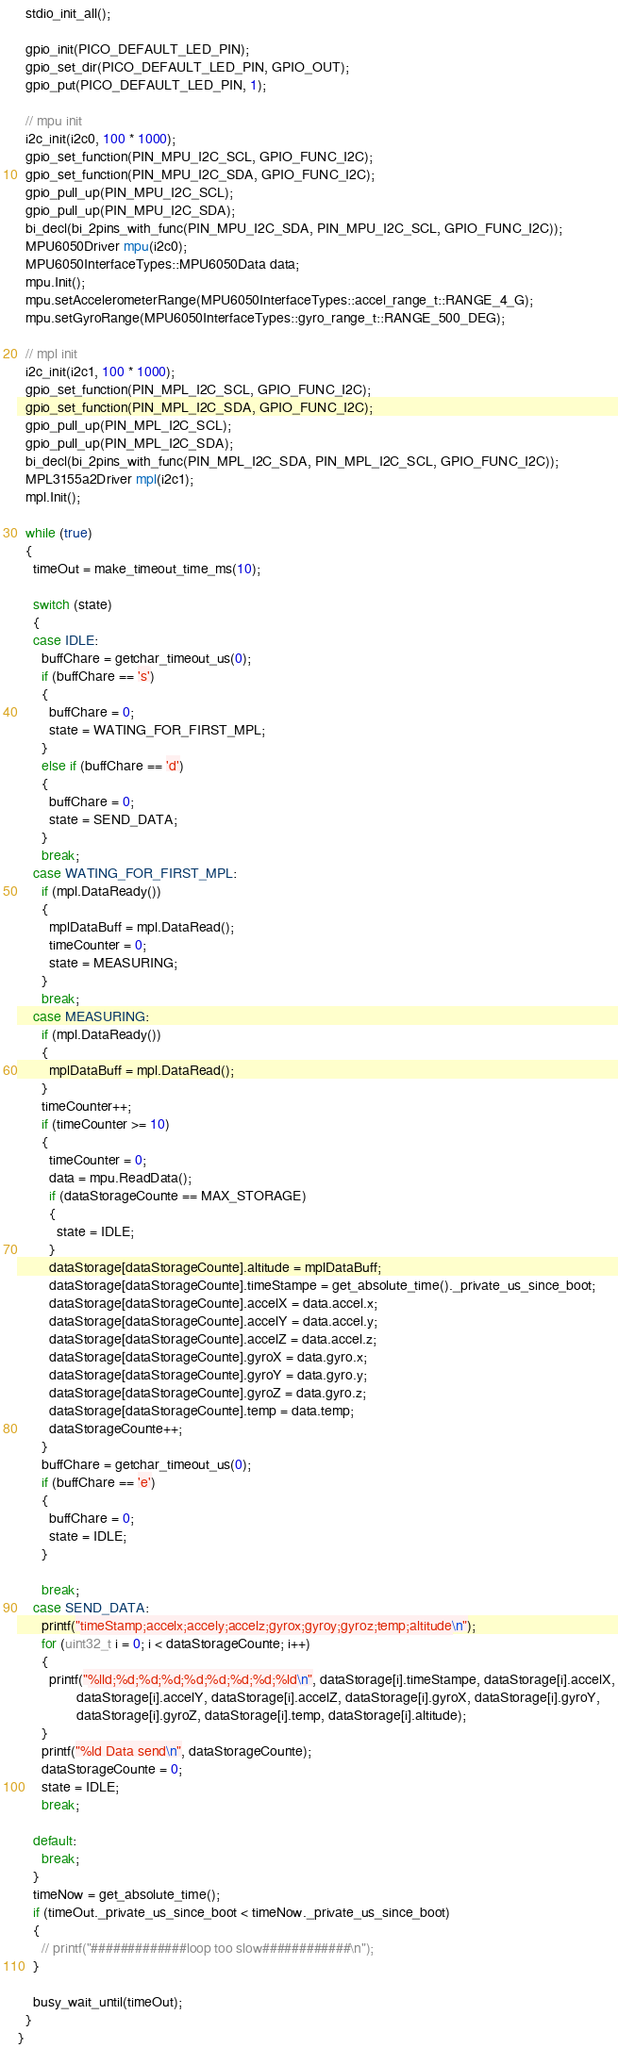Convert code to text. <code><loc_0><loc_0><loc_500><loc_500><_C++_>
  stdio_init_all();

  gpio_init(PICO_DEFAULT_LED_PIN);
  gpio_set_dir(PICO_DEFAULT_LED_PIN, GPIO_OUT);
  gpio_put(PICO_DEFAULT_LED_PIN, 1);

  // mpu init
  i2c_init(i2c0, 100 * 1000);
  gpio_set_function(PIN_MPU_I2C_SCL, GPIO_FUNC_I2C);
  gpio_set_function(PIN_MPU_I2C_SDA, GPIO_FUNC_I2C);
  gpio_pull_up(PIN_MPU_I2C_SCL);
  gpio_pull_up(PIN_MPU_I2C_SDA);
  bi_decl(bi_2pins_with_func(PIN_MPU_I2C_SDA, PIN_MPU_I2C_SCL, GPIO_FUNC_I2C));
  MPU6050Driver mpu(i2c0);
  MPU6050InterfaceTypes::MPU6050Data data;
  mpu.Init();
  mpu.setAccelerometerRange(MPU6050InterfaceTypes::accel_range_t::RANGE_4_G);
  mpu.setGyroRange(MPU6050InterfaceTypes::gyro_range_t::RANGE_500_DEG);

  // mpl init
  i2c_init(i2c1, 100 * 1000);
  gpio_set_function(PIN_MPL_I2C_SCL, GPIO_FUNC_I2C);
  gpio_set_function(PIN_MPL_I2C_SDA, GPIO_FUNC_I2C);
  gpio_pull_up(PIN_MPL_I2C_SCL);
  gpio_pull_up(PIN_MPL_I2C_SDA);
  bi_decl(bi_2pins_with_func(PIN_MPL_I2C_SDA, PIN_MPL_I2C_SCL, GPIO_FUNC_I2C));
  MPL3155a2Driver mpl(i2c1);
  mpl.Init();

  while (true)
  {
    timeOut = make_timeout_time_ms(10);

    switch (state)
    {
    case IDLE:
      buffChare = getchar_timeout_us(0);
      if (buffChare == 's')
      {
        buffChare = 0;
        state = WATING_FOR_FIRST_MPL;
      }
      else if (buffChare == 'd')
      {
        buffChare = 0;
        state = SEND_DATA;
      }
      break;
    case WATING_FOR_FIRST_MPL:
      if (mpl.DataReady())
      {
        mplDataBuff = mpl.DataRead();
        timeCounter = 0;
        state = MEASURING;
      }
      break;
    case MEASURING:
      if (mpl.DataReady())
      {
        mplDataBuff = mpl.DataRead();
      }
      timeCounter++;
      if (timeCounter >= 10)
      {
        timeCounter = 0;
        data = mpu.ReadData();
        if (dataStorageCounte == MAX_STORAGE)
        {
          state = IDLE;
        }
        dataStorage[dataStorageCounte].altitude = mplDataBuff;
        dataStorage[dataStorageCounte].timeStampe = get_absolute_time()._private_us_since_boot;
        dataStorage[dataStorageCounte].accelX = data.accel.x;
        dataStorage[dataStorageCounte].accelY = data.accel.y;
        dataStorage[dataStorageCounte].accelZ = data.accel.z;
        dataStorage[dataStorageCounte].gyroX = data.gyro.x;
        dataStorage[dataStorageCounte].gyroY = data.gyro.y;
        dataStorage[dataStorageCounte].gyroZ = data.gyro.z;
        dataStorage[dataStorageCounte].temp = data.temp;
        dataStorageCounte++;
      }
      buffChare = getchar_timeout_us(0);
      if (buffChare == 'e')
      {
        buffChare = 0;
        state = IDLE;
      }

      break;
    case SEND_DATA:
      printf("timeStamp;accelx;accely;accelz;gyrox;gyroy;gyroz;temp;altitude\n");
      for (uint32_t i = 0; i < dataStorageCounte; i++)
      {
        printf("%lld;%d;%d;%d;%d;%d;%d;%d;%ld\n", dataStorage[i].timeStampe, dataStorage[i].accelX,
               dataStorage[i].accelY, dataStorage[i].accelZ, dataStorage[i].gyroX, dataStorage[i].gyroY,
               dataStorage[i].gyroZ, dataStorage[i].temp, dataStorage[i].altitude);
      }
      printf("%ld Data send\n", dataStorageCounte);
      dataStorageCounte = 0;
      state = IDLE;
      break;

    default:
      break;
    }
    timeNow = get_absolute_time();
    if (timeOut._private_us_since_boot < timeNow._private_us_since_boot)
    {
      // printf("#############loop too slow############\n");
    }

    busy_wait_until(timeOut);
  }
}</code> 